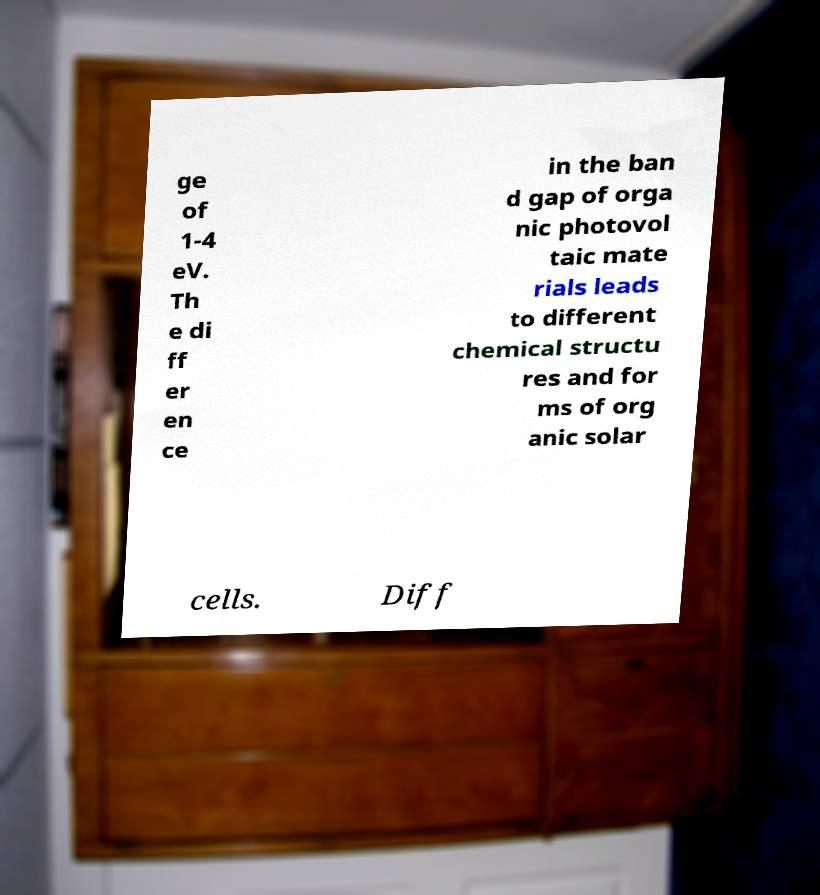There's text embedded in this image that I need extracted. Can you transcribe it verbatim? ge of 1-4 eV. Th e di ff er en ce in the ban d gap of orga nic photovol taic mate rials leads to different chemical structu res and for ms of org anic solar cells. Diff 